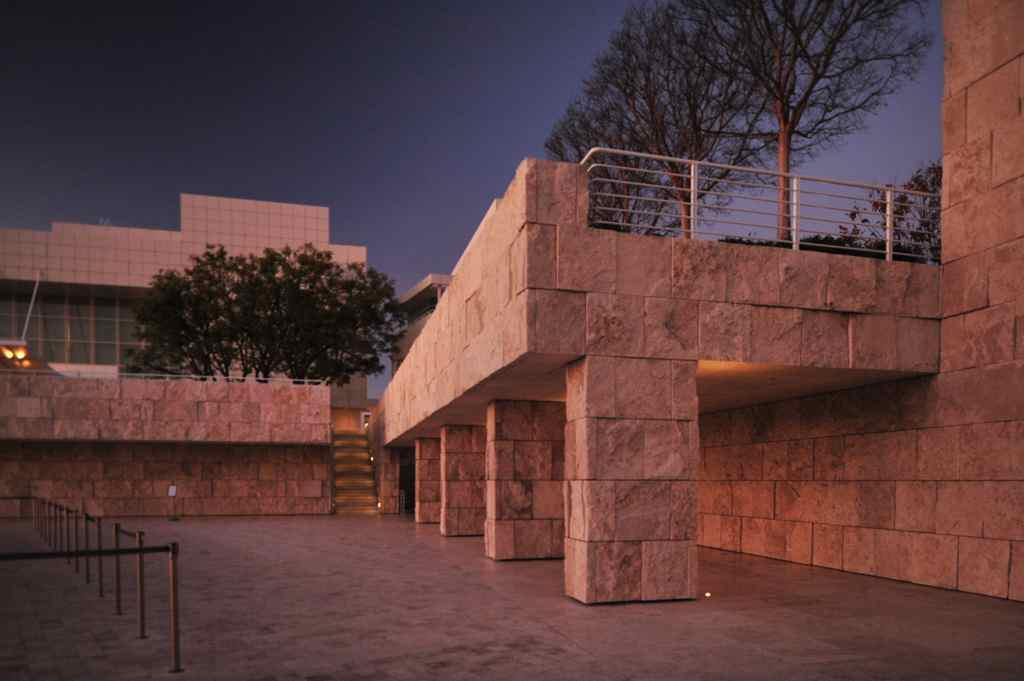What type of structures can be seen in the image? There are buildings in the image. What architectural feature is present in the image? There are steps, rods, pillars, and railing in the image. What type of vegetation is visible in the image? There are trees in the image. What type of lighting is present in the image? There are lights in the image. What part of the natural environment is visible in the image? The sky is visible in the image. Can you see a tray being carried by someone in the image? There is no tray visible in the image, nor is anyone carrying a tray. How many leaves can be counted on the trees in the image? There are no leaves visible in the image, as it is not specified whether the trees are deciduous or evergreen. 